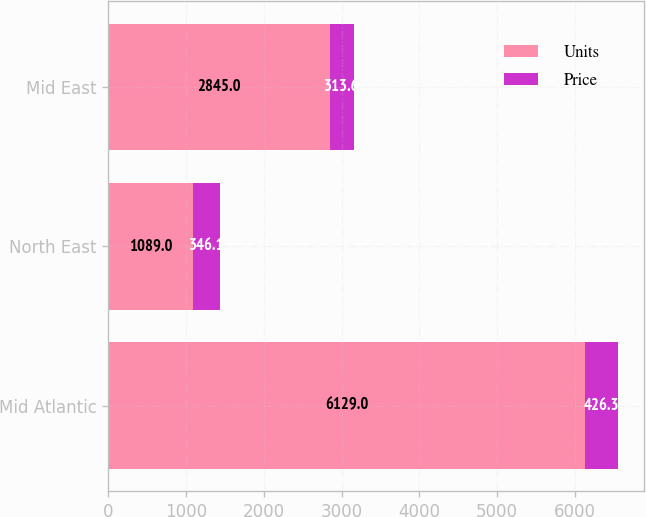Convert chart to OTSL. <chart><loc_0><loc_0><loc_500><loc_500><stacked_bar_chart><ecel><fcel>Mid Atlantic<fcel>North East<fcel>Mid East<nl><fcel>Units<fcel>6129<fcel>1089<fcel>2845<nl><fcel>Price<fcel>426.3<fcel>346.1<fcel>313.6<nl></chart> 